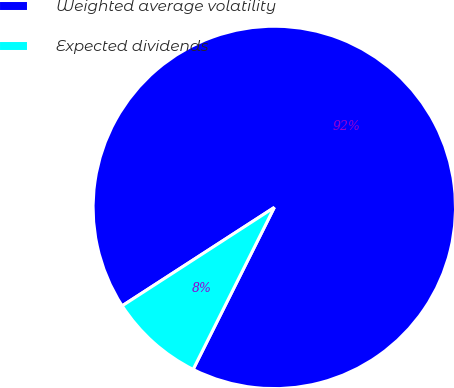<chart> <loc_0><loc_0><loc_500><loc_500><pie_chart><fcel>Weighted average volatility<fcel>Expected dividends<nl><fcel>91.53%<fcel>8.47%<nl></chart> 